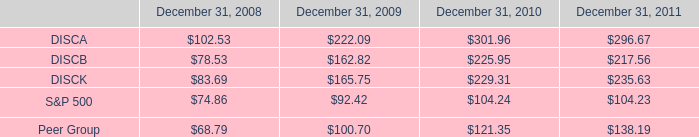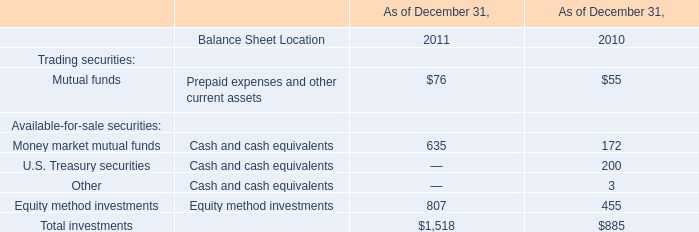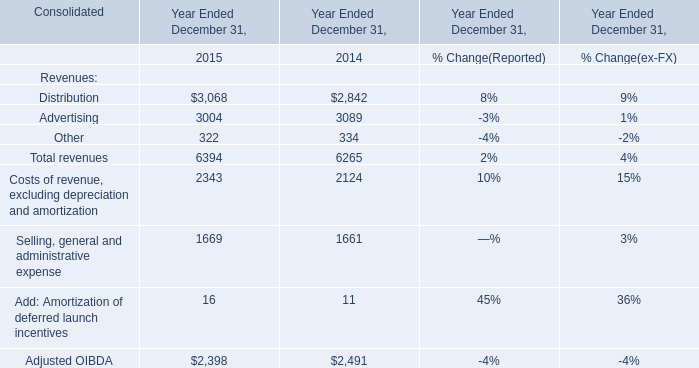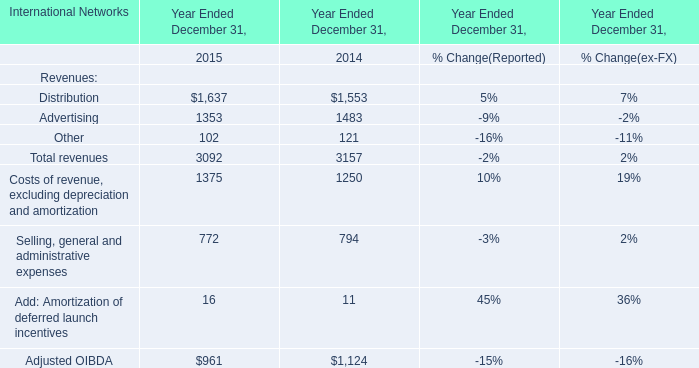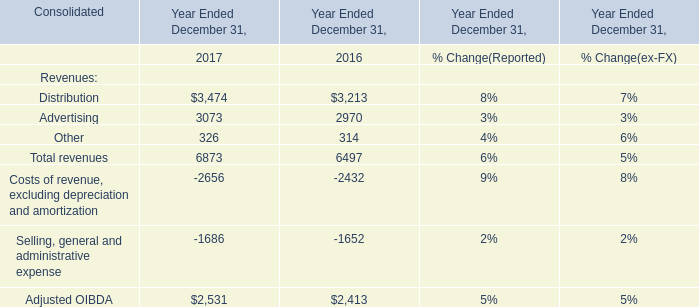the k series stock outperformed the s&p 500 by what percent over 5 years? 
Computations: ((235.63 - 104.23) / 104.23)
Answer: 1.26067. 